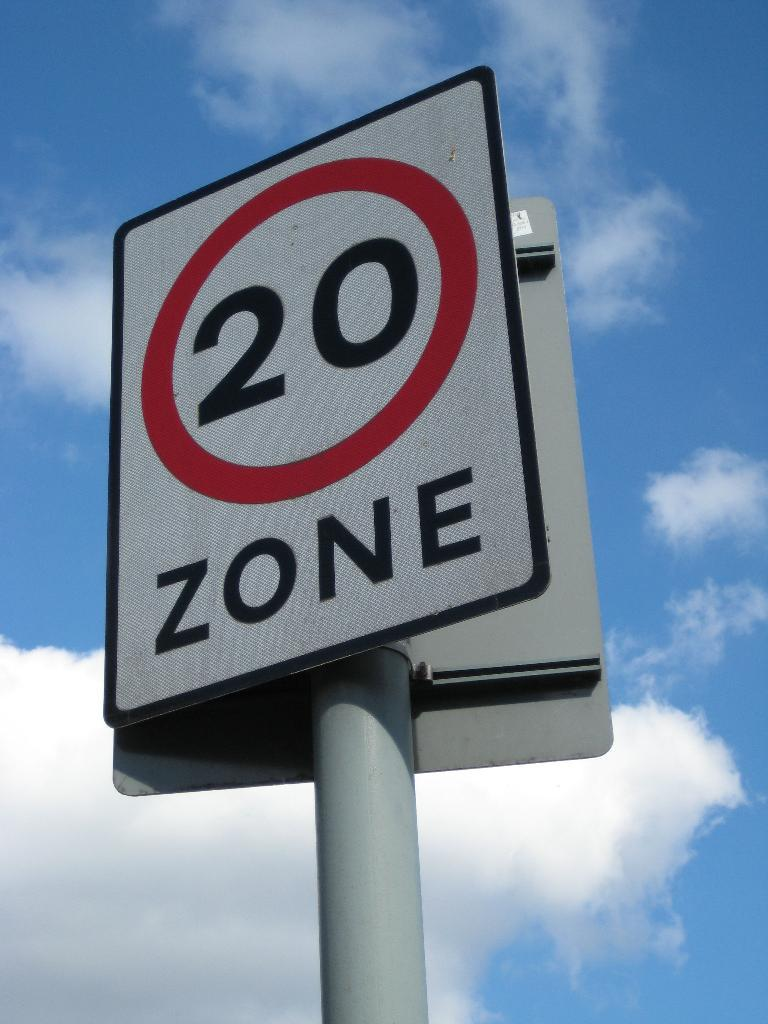Provide a one-sentence caption for the provided image. Road sign that says twenty zone on a white sign. 